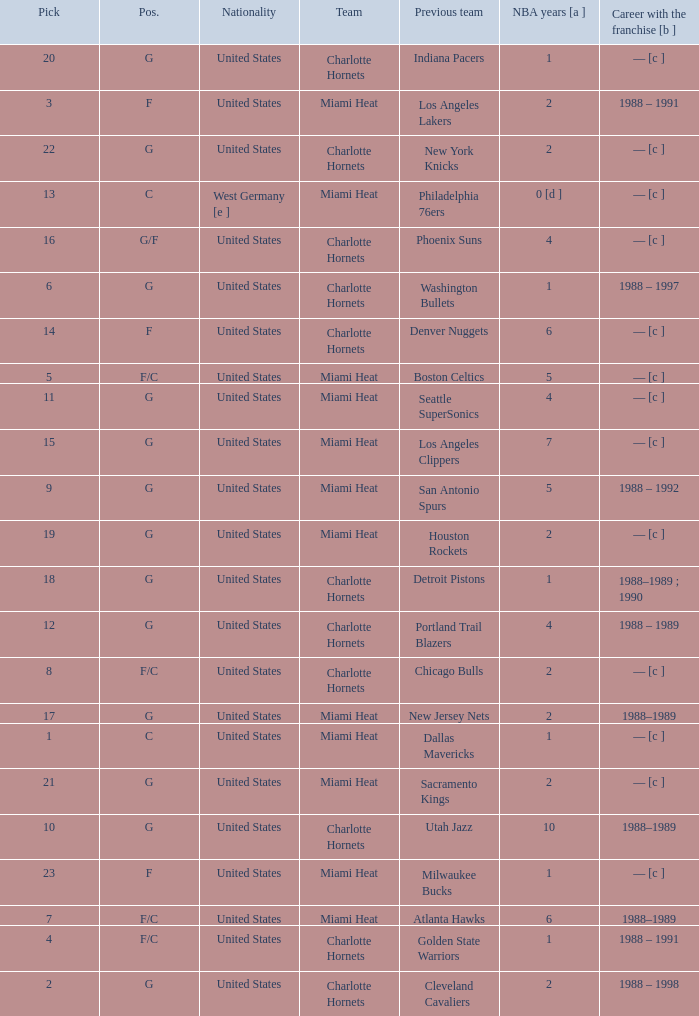What is the previous team of the player with 4 NBA years and a pick less than 16? Seattle SuperSonics, Portland Trail Blazers. 